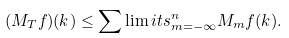<formula> <loc_0><loc_0><loc_500><loc_500>( M _ { T } f ) ( k ) \leq \sum \lim i t s ^ { n } _ { m = - \infty } M _ { m } f ( k ) .</formula> 